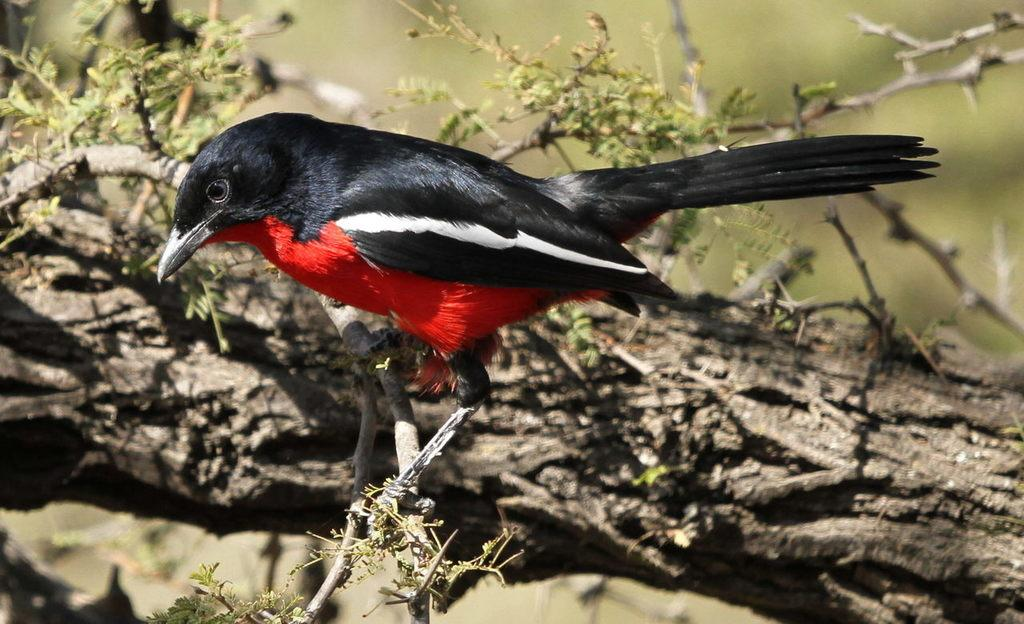What type of animal can be seen in the image? There is a bird in the image. Where is the bird located in the image? The bird is standing on the stem of a tree. What colors can be seen on the bird? The bird has black, red, and white colors. Is there any specific marking on the bird? Yes, the bird has a white stripe on it. What nation does the bird represent in the image? The image does not depict the bird representing any nation. How does the bird sneeze in the image? Birds do not sneeze, and there is no indication of the bird sneezing in the image. 